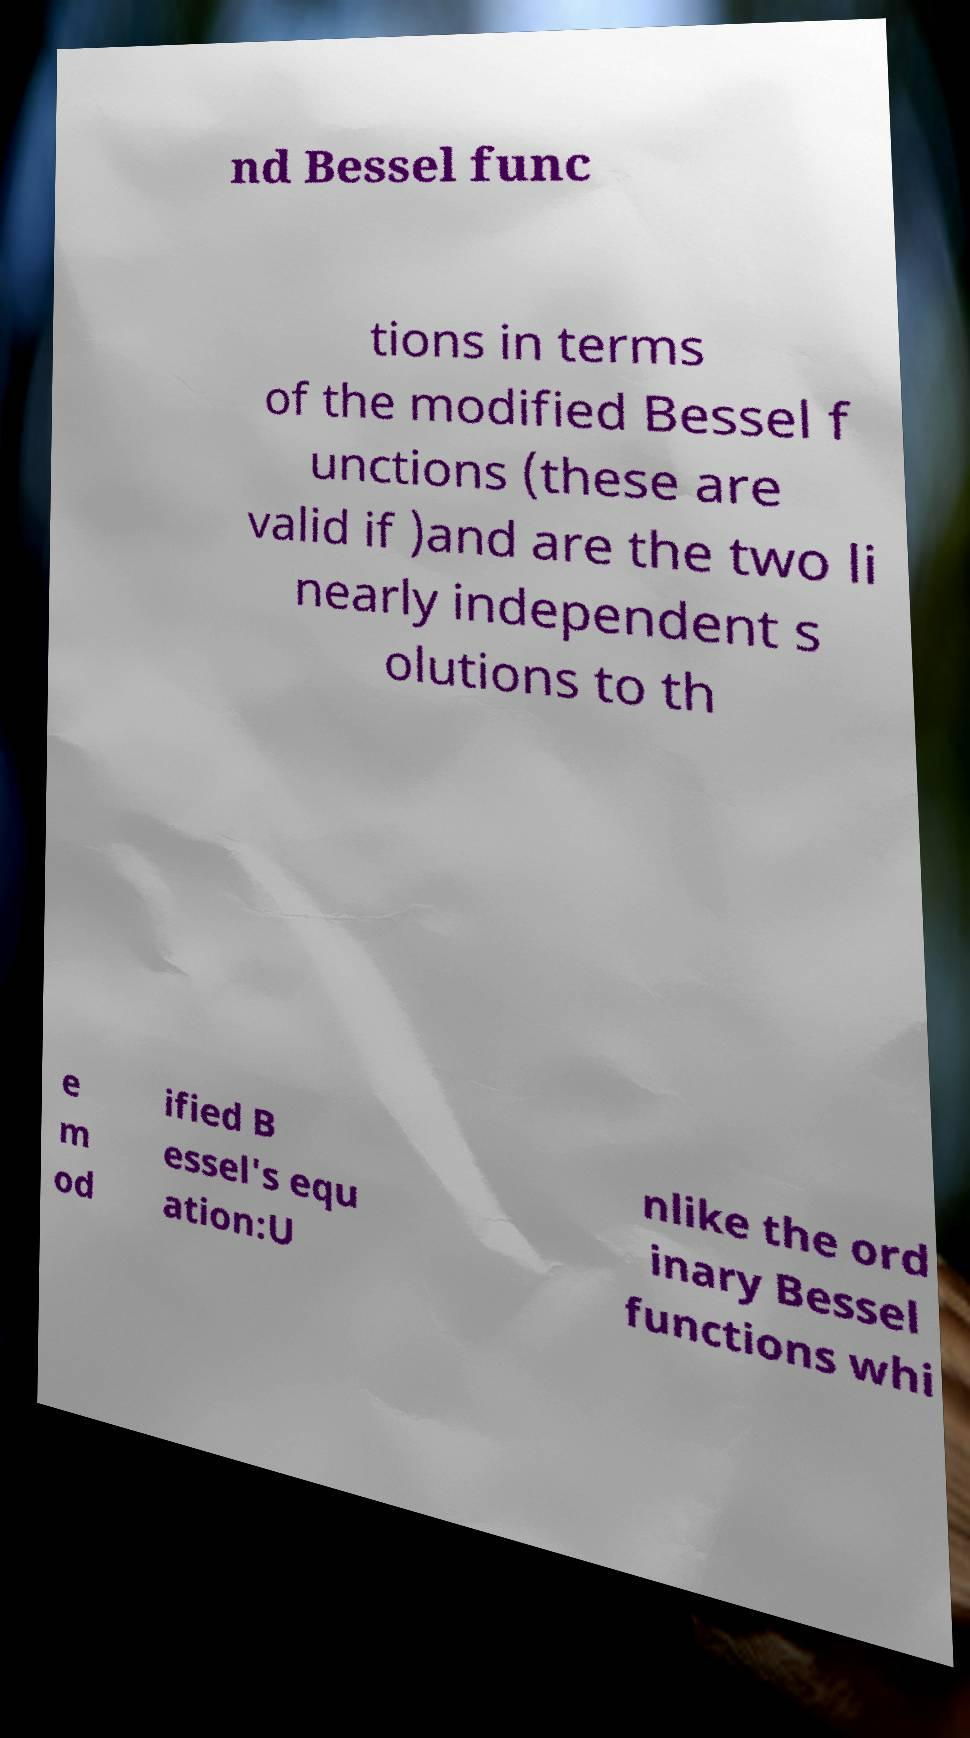For documentation purposes, I need the text within this image transcribed. Could you provide that? nd Bessel func tions in terms of the modified Bessel f unctions (these are valid if )and are the two li nearly independent s olutions to th e m od ified B essel's equ ation:U nlike the ord inary Bessel functions whi 